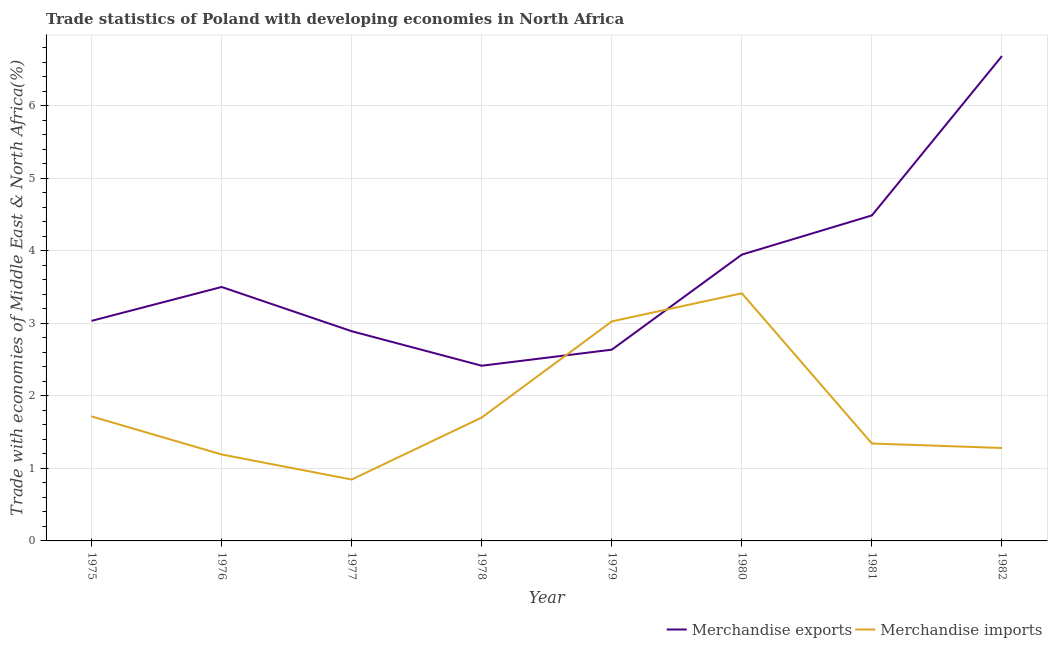Is the number of lines equal to the number of legend labels?
Make the answer very short. Yes. What is the merchandise exports in 1975?
Provide a short and direct response. 3.03. Across all years, what is the maximum merchandise exports?
Provide a short and direct response. 6.69. Across all years, what is the minimum merchandise exports?
Your response must be concise. 2.42. In which year was the merchandise exports minimum?
Make the answer very short. 1978. What is the total merchandise exports in the graph?
Your answer should be very brief. 29.6. What is the difference between the merchandise exports in 1976 and that in 1978?
Give a very brief answer. 1.09. What is the difference between the merchandise imports in 1976 and the merchandise exports in 1981?
Provide a short and direct response. -3.3. What is the average merchandise imports per year?
Your answer should be very brief. 1.82. In the year 1976, what is the difference between the merchandise imports and merchandise exports?
Give a very brief answer. -2.31. What is the ratio of the merchandise imports in 1978 to that in 1980?
Ensure brevity in your answer.  0.5. What is the difference between the highest and the second highest merchandise exports?
Offer a very short reply. 2.2. What is the difference between the highest and the lowest merchandise imports?
Your answer should be very brief. 2.57. In how many years, is the merchandise exports greater than the average merchandise exports taken over all years?
Provide a succinct answer. 3. How many years are there in the graph?
Offer a terse response. 8. What is the difference between two consecutive major ticks on the Y-axis?
Provide a short and direct response. 1. Are the values on the major ticks of Y-axis written in scientific E-notation?
Keep it short and to the point. No. Does the graph contain any zero values?
Ensure brevity in your answer.  No. How many legend labels are there?
Offer a terse response. 2. How are the legend labels stacked?
Keep it short and to the point. Horizontal. What is the title of the graph?
Offer a terse response. Trade statistics of Poland with developing economies in North Africa. What is the label or title of the Y-axis?
Offer a very short reply. Trade with economies of Middle East & North Africa(%). What is the Trade with economies of Middle East & North Africa(%) in Merchandise exports in 1975?
Provide a succinct answer. 3.03. What is the Trade with economies of Middle East & North Africa(%) in Merchandise imports in 1975?
Your answer should be very brief. 1.72. What is the Trade with economies of Middle East & North Africa(%) of Merchandise exports in 1976?
Provide a short and direct response. 3.5. What is the Trade with economies of Middle East & North Africa(%) of Merchandise imports in 1976?
Offer a terse response. 1.19. What is the Trade with economies of Middle East & North Africa(%) of Merchandise exports in 1977?
Ensure brevity in your answer.  2.89. What is the Trade with economies of Middle East & North Africa(%) in Merchandise imports in 1977?
Offer a terse response. 0.85. What is the Trade with economies of Middle East & North Africa(%) in Merchandise exports in 1978?
Provide a short and direct response. 2.42. What is the Trade with economies of Middle East & North Africa(%) in Merchandise imports in 1978?
Make the answer very short. 1.7. What is the Trade with economies of Middle East & North Africa(%) in Merchandise exports in 1979?
Your answer should be very brief. 2.64. What is the Trade with economies of Middle East & North Africa(%) in Merchandise imports in 1979?
Give a very brief answer. 3.03. What is the Trade with economies of Middle East & North Africa(%) of Merchandise exports in 1980?
Give a very brief answer. 3.95. What is the Trade with economies of Middle East & North Africa(%) of Merchandise imports in 1980?
Make the answer very short. 3.41. What is the Trade with economies of Middle East & North Africa(%) in Merchandise exports in 1981?
Keep it short and to the point. 4.49. What is the Trade with economies of Middle East & North Africa(%) in Merchandise imports in 1981?
Provide a short and direct response. 1.34. What is the Trade with economies of Middle East & North Africa(%) of Merchandise exports in 1982?
Offer a very short reply. 6.69. What is the Trade with economies of Middle East & North Africa(%) of Merchandise imports in 1982?
Offer a terse response. 1.28. Across all years, what is the maximum Trade with economies of Middle East & North Africa(%) of Merchandise exports?
Make the answer very short. 6.69. Across all years, what is the maximum Trade with economies of Middle East & North Africa(%) in Merchandise imports?
Provide a succinct answer. 3.41. Across all years, what is the minimum Trade with economies of Middle East & North Africa(%) in Merchandise exports?
Make the answer very short. 2.42. Across all years, what is the minimum Trade with economies of Middle East & North Africa(%) of Merchandise imports?
Give a very brief answer. 0.85. What is the total Trade with economies of Middle East & North Africa(%) of Merchandise exports in the graph?
Provide a short and direct response. 29.6. What is the total Trade with economies of Middle East & North Africa(%) in Merchandise imports in the graph?
Offer a terse response. 14.52. What is the difference between the Trade with economies of Middle East & North Africa(%) in Merchandise exports in 1975 and that in 1976?
Your response must be concise. -0.47. What is the difference between the Trade with economies of Middle East & North Africa(%) in Merchandise imports in 1975 and that in 1976?
Your answer should be compact. 0.52. What is the difference between the Trade with economies of Middle East & North Africa(%) in Merchandise exports in 1975 and that in 1977?
Give a very brief answer. 0.14. What is the difference between the Trade with economies of Middle East & North Africa(%) of Merchandise imports in 1975 and that in 1977?
Provide a succinct answer. 0.87. What is the difference between the Trade with economies of Middle East & North Africa(%) in Merchandise exports in 1975 and that in 1978?
Your response must be concise. 0.62. What is the difference between the Trade with economies of Middle East & North Africa(%) in Merchandise imports in 1975 and that in 1978?
Provide a short and direct response. 0.02. What is the difference between the Trade with economies of Middle East & North Africa(%) of Merchandise exports in 1975 and that in 1979?
Provide a succinct answer. 0.4. What is the difference between the Trade with economies of Middle East & North Africa(%) in Merchandise imports in 1975 and that in 1979?
Keep it short and to the point. -1.31. What is the difference between the Trade with economies of Middle East & North Africa(%) of Merchandise exports in 1975 and that in 1980?
Make the answer very short. -0.91. What is the difference between the Trade with economies of Middle East & North Africa(%) of Merchandise imports in 1975 and that in 1980?
Provide a short and direct response. -1.7. What is the difference between the Trade with economies of Middle East & North Africa(%) of Merchandise exports in 1975 and that in 1981?
Offer a terse response. -1.45. What is the difference between the Trade with economies of Middle East & North Africa(%) of Merchandise imports in 1975 and that in 1981?
Ensure brevity in your answer.  0.37. What is the difference between the Trade with economies of Middle East & North Africa(%) of Merchandise exports in 1975 and that in 1982?
Your answer should be very brief. -3.65. What is the difference between the Trade with economies of Middle East & North Africa(%) of Merchandise imports in 1975 and that in 1982?
Your response must be concise. 0.44. What is the difference between the Trade with economies of Middle East & North Africa(%) of Merchandise exports in 1976 and that in 1977?
Keep it short and to the point. 0.61. What is the difference between the Trade with economies of Middle East & North Africa(%) of Merchandise imports in 1976 and that in 1977?
Provide a short and direct response. 0.35. What is the difference between the Trade with economies of Middle East & North Africa(%) in Merchandise exports in 1976 and that in 1978?
Your answer should be very brief. 1.09. What is the difference between the Trade with economies of Middle East & North Africa(%) of Merchandise imports in 1976 and that in 1978?
Provide a short and direct response. -0.51. What is the difference between the Trade with economies of Middle East & North Africa(%) in Merchandise exports in 1976 and that in 1979?
Your answer should be very brief. 0.86. What is the difference between the Trade with economies of Middle East & North Africa(%) in Merchandise imports in 1976 and that in 1979?
Your response must be concise. -1.83. What is the difference between the Trade with economies of Middle East & North Africa(%) of Merchandise exports in 1976 and that in 1980?
Keep it short and to the point. -0.45. What is the difference between the Trade with economies of Middle East & North Africa(%) in Merchandise imports in 1976 and that in 1980?
Your response must be concise. -2.22. What is the difference between the Trade with economies of Middle East & North Africa(%) of Merchandise exports in 1976 and that in 1981?
Keep it short and to the point. -0.99. What is the difference between the Trade with economies of Middle East & North Africa(%) of Merchandise imports in 1976 and that in 1981?
Your answer should be compact. -0.15. What is the difference between the Trade with economies of Middle East & North Africa(%) of Merchandise exports in 1976 and that in 1982?
Make the answer very short. -3.18. What is the difference between the Trade with economies of Middle East & North Africa(%) in Merchandise imports in 1976 and that in 1982?
Make the answer very short. -0.09. What is the difference between the Trade with economies of Middle East & North Africa(%) in Merchandise exports in 1977 and that in 1978?
Make the answer very short. 0.48. What is the difference between the Trade with economies of Middle East & North Africa(%) in Merchandise imports in 1977 and that in 1978?
Provide a short and direct response. -0.86. What is the difference between the Trade with economies of Middle East & North Africa(%) in Merchandise exports in 1977 and that in 1979?
Make the answer very short. 0.25. What is the difference between the Trade with economies of Middle East & North Africa(%) in Merchandise imports in 1977 and that in 1979?
Your answer should be very brief. -2.18. What is the difference between the Trade with economies of Middle East & North Africa(%) of Merchandise exports in 1977 and that in 1980?
Your answer should be compact. -1.06. What is the difference between the Trade with economies of Middle East & North Africa(%) in Merchandise imports in 1977 and that in 1980?
Your answer should be compact. -2.57. What is the difference between the Trade with economies of Middle East & North Africa(%) in Merchandise exports in 1977 and that in 1981?
Ensure brevity in your answer.  -1.6. What is the difference between the Trade with economies of Middle East & North Africa(%) in Merchandise imports in 1977 and that in 1981?
Offer a very short reply. -0.5. What is the difference between the Trade with economies of Middle East & North Africa(%) in Merchandise exports in 1977 and that in 1982?
Make the answer very short. -3.79. What is the difference between the Trade with economies of Middle East & North Africa(%) of Merchandise imports in 1977 and that in 1982?
Offer a very short reply. -0.44. What is the difference between the Trade with economies of Middle East & North Africa(%) in Merchandise exports in 1978 and that in 1979?
Give a very brief answer. -0.22. What is the difference between the Trade with economies of Middle East & North Africa(%) in Merchandise imports in 1978 and that in 1979?
Your answer should be compact. -1.33. What is the difference between the Trade with economies of Middle East & North Africa(%) in Merchandise exports in 1978 and that in 1980?
Offer a very short reply. -1.53. What is the difference between the Trade with economies of Middle East & North Africa(%) in Merchandise imports in 1978 and that in 1980?
Provide a succinct answer. -1.71. What is the difference between the Trade with economies of Middle East & North Africa(%) in Merchandise exports in 1978 and that in 1981?
Give a very brief answer. -2.07. What is the difference between the Trade with economies of Middle East & North Africa(%) in Merchandise imports in 1978 and that in 1981?
Make the answer very short. 0.36. What is the difference between the Trade with economies of Middle East & North Africa(%) in Merchandise exports in 1978 and that in 1982?
Ensure brevity in your answer.  -4.27. What is the difference between the Trade with economies of Middle East & North Africa(%) in Merchandise imports in 1978 and that in 1982?
Give a very brief answer. 0.42. What is the difference between the Trade with economies of Middle East & North Africa(%) in Merchandise exports in 1979 and that in 1980?
Offer a very short reply. -1.31. What is the difference between the Trade with economies of Middle East & North Africa(%) in Merchandise imports in 1979 and that in 1980?
Your response must be concise. -0.39. What is the difference between the Trade with economies of Middle East & North Africa(%) in Merchandise exports in 1979 and that in 1981?
Your answer should be compact. -1.85. What is the difference between the Trade with economies of Middle East & North Africa(%) in Merchandise imports in 1979 and that in 1981?
Offer a very short reply. 1.68. What is the difference between the Trade with economies of Middle East & North Africa(%) of Merchandise exports in 1979 and that in 1982?
Keep it short and to the point. -4.05. What is the difference between the Trade with economies of Middle East & North Africa(%) in Merchandise imports in 1979 and that in 1982?
Provide a succinct answer. 1.75. What is the difference between the Trade with economies of Middle East & North Africa(%) in Merchandise exports in 1980 and that in 1981?
Offer a terse response. -0.54. What is the difference between the Trade with economies of Middle East & North Africa(%) of Merchandise imports in 1980 and that in 1981?
Your answer should be very brief. 2.07. What is the difference between the Trade with economies of Middle East & North Africa(%) in Merchandise exports in 1980 and that in 1982?
Give a very brief answer. -2.74. What is the difference between the Trade with economies of Middle East & North Africa(%) in Merchandise imports in 1980 and that in 1982?
Provide a succinct answer. 2.13. What is the difference between the Trade with economies of Middle East & North Africa(%) in Merchandise exports in 1981 and that in 1982?
Your answer should be very brief. -2.2. What is the difference between the Trade with economies of Middle East & North Africa(%) in Merchandise imports in 1981 and that in 1982?
Your response must be concise. 0.06. What is the difference between the Trade with economies of Middle East & North Africa(%) of Merchandise exports in 1975 and the Trade with economies of Middle East & North Africa(%) of Merchandise imports in 1976?
Give a very brief answer. 1.84. What is the difference between the Trade with economies of Middle East & North Africa(%) in Merchandise exports in 1975 and the Trade with economies of Middle East & North Africa(%) in Merchandise imports in 1977?
Your response must be concise. 2.19. What is the difference between the Trade with economies of Middle East & North Africa(%) of Merchandise exports in 1975 and the Trade with economies of Middle East & North Africa(%) of Merchandise imports in 1978?
Your answer should be compact. 1.33. What is the difference between the Trade with economies of Middle East & North Africa(%) of Merchandise exports in 1975 and the Trade with economies of Middle East & North Africa(%) of Merchandise imports in 1979?
Ensure brevity in your answer.  0.01. What is the difference between the Trade with economies of Middle East & North Africa(%) in Merchandise exports in 1975 and the Trade with economies of Middle East & North Africa(%) in Merchandise imports in 1980?
Keep it short and to the point. -0.38. What is the difference between the Trade with economies of Middle East & North Africa(%) of Merchandise exports in 1975 and the Trade with economies of Middle East & North Africa(%) of Merchandise imports in 1981?
Keep it short and to the point. 1.69. What is the difference between the Trade with economies of Middle East & North Africa(%) of Merchandise exports in 1975 and the Trade with economies of Middle East & North Africa(%) of Merchandise imports in 1982?
Provide a short and direct response. 1.75. What is the difference between the Trade with economies of Middle East & North Africa(%) of Merchandise exports in 1976 and the Trade with economies of Middle East & North Africa(%) of Merchandise imports in 1977?
Keep it short and to the point. 2.65. What is the difference between the Trade with economies of Middle East & North Africa(%) of Merchandise exports in 1976 and the Trade with economies of Middle East & North Africa(%) of Merchandise imports in 1978?
Offer a very short reply. 1.8. What is the difference between the Trade with economies of Middle East & North Africa(%) of Merchandise exports in 1976 and the Trade with economies of Middle East & North Africa(%) of Merchandise imports in 1979?
Ensure brevity in your answer.  0.47. What is the difference between the Trade with economies of Middle East & North Africa(%) in Merchandise exports in 1976 and the Trade with economies of Middle East & North Africa(%) in Merchandise imports in 1980?
Ensure brevity in your answer.  0.09. What is the difference between the Trade with economies of Middle East & North Africa(%) in Merchandise exports in 1976 and the Trade with economies of Middle East & North Africa(%) in Merchandise imports in 1981?
Offer a terse response. 2.16. What is the difference between the Trade with economies of Middle East & North Africa(%) in Merchandise exports in 1976 and the Trade with economies of Middle East & North Africa(%) in Merchandise imports in 1982?
Keep it short and to the point. 2.22. What is the difference between the Trade with economies of Middle East & North Africa(%) in Merchandise exports in 1977 and the Trade with economies of Middle East & North Africa(%) in Merchandise imports in 1978?
Give a very brief answer. 1.19. What is the difference between the Trade with economies of Middle East & North Africa(%) of Merchandise exports in 1977 and the Trade with economies of Middle East & North Africa(%) of Merchandise imports in 1979?
Offer a very short reply. -0.14. What is the difference between the Trade with economies of Middle East & North Africa(%) of Merchandise exports in 1977 and the Trade with economies of Middle East & North Africa(%) of Merchandise imports in 1980?
Give a very brief answer. -0.52. What is the difference between the Trade with economies of Middle East & North Africa(%) in Merchandise exports in 1977 and the Trade with economies of Middle East & North Africa(%) in Merchandise imports in 1981?
Offer a very short reply. 1.55. What is the difference between the Trade with economies of Middle East & North Africa(%) in Merchandise exports in 1977 and the Trade with economies of Middle East & North Africa(%) in Merchandise imports in 1982?
Ensure brevity in your answer.  1.61. What is the difference between the Trade with economies of Middle East & North Africa(%) in Merchandise exports in 1978 and the Trade with economies of Middle East & North Africa(%) in Merchandise imports in 1979?
Keep it short and to the point. -0.61. What is the difference between the Trade with economies of Middle East & North Africa(%) in Merchandise exports in 1978 and the Trade with economies of Middle East & North Africa(%) in Merchandise imports in 1980?
Make the answer very short. -1. What is the difference between the Trade with economies of Middle East & North Africa(%) of Merchandise exports in 1978 and the Trade with economies of Middle East & North Africa(%) of Merchandise imports in 1981?
Keep it short and to the point. 1.07. What is the difference between the Trade with economies of Middle East & North Africa(%) in Merchandise exports in 1978 and the Trade with economies of Middle East & North Africa(%) in Merchandise imports in 1982?
Ensure brevity in your answer.  1.13. What is the difference between the Trade with economies of Middle East & North Africa(%) of Merchandise exports in 1979 and the Trade with economies of Middle East & North Africa(%) of Merchandise imports in 1980?
Your answer should be compact. -0.78. What is the difference between the Trade with economies of Middle East & North Africa(%) in Merchandise exports in 1979 and the Trade with economies of Middle East & North Africa(%) in Merchandise imports in 1981?
Offer a very short reply. 1.29. What is the difference between the Trade with economies of Middle East & North Africa(%) in Merchandise exports in 1979 and the Trade with economies of Middle East & North Africa(%) in Merchandise imports in 1982?
Your answer should be compact. 1.36. What is the difference between the Trade with economies of Middle East & North Africa(%) of Merchandise exports in 1980 and the Trade with economies of Middle East & North Africa(%) of Merchandise imports in 1981?
Offer a very short reply. 2.6. What is the difference between the Trade with economies of Middle East & North Africa(%) of Merchandise exports in 1980 and the Trade with economies of Middle East & North Africa(%) of Merchandise imports in 1982?
Make the answer very short. 2.67. What is the difference between the Trade with economies of Middle East & North Africa(%) of Merchandise exports in 1981 and the Trade with economies of Middle East & North Africa(%) of Merchandise imports in 1982?
Ensure brevity in your answer.  3.21. What is the average Trade with economies of Middle East & North Africa(%) in Merchandise imports per year?
Your answer should be very brief. 1.82. In the year 1975, what is the difference between the Trade with economies of Middle East & North Africa(%) of Merchandise exports and Trade with economies of Middle East & North Africa(%) of Merchandise imports?
Provide a short and direct response. 1.32. In the year 1976, what is the difference between the Trade with economies of Middle East & North Africa(%) of Merchandise exports and Trade with economies of Middle East & North Africa(%) of Merchandise imports?
Provide a short and direct response. 2.31. In the year 1977, what is the difference between the Trade with economies of Middle East & North Africa(%) of Merchandise exports and Trade with economies of Middle East & North Africa(%) of Merchandise imports?
Keep it short and to the point. 2.04. In the year 1978, what is the difference between the Trade with economies of Middle East & North Africa(%) in Merchandise exports and Trade with economies of Middle East & North Africa(%) in Merchandise imports?
Offer a very short reply. 0.71. In the year 1979, what is the difference between the Trade with economies of Middle East & North Africa(%) in Merchandise exports and Trade with economies of Middle East & North Africa(%) in Merchandise imports?
Offer a terse response. -0.39. In the year 1980, what is the difference between the Trade with economies of Middle East & North Africa(%) in Merchandise exports and Trade with economies of Middle East & North Africa(%) in Merchandise imports?
Your answer should be very brief. 0.53. In the year 1981, what is the difference between the Trade with economies of Middle East & North Africa(%) of Merchandise exports and Trade with economies of Middle East & North Africa(%) of Merchandise imports?
Give a very brief answer. 3.14. In the year 1982, what is the difference between the Trade with economies of Middle East & North Africa(%) of Merchandise exports and Trade with economies of Middle East & North Africa(%) of Merchandise imports?
Make the answer very short. 5.4. What is the ratio of the Trade with economies of Middle East & North Africa(%) in Merchandise exports in 1975 to that in 1976?
Give a very brief answer. 0.87. What is the ratio of the Trade with economies of Middle East & North Africa(%) in Merchandise imports in 1975 to that in 1976?
Offer a terse response. 1.44. What is the ratio of the Trade with economies of Middle East & North Africa(%) of Merchandise exports in 1975 to that in 1977?
Ensure brevity in your answer.  1.05. What is the ratio of the Trade with economies of Middle East & North Africa(%) of Merchandise imports in 1975 to that in 1977?
Your answer should be compact. 2.03. What is the ratio of the Trade with economies of Middle East & North Africa(%) of Merchandise exports in 1975 to that in 1978?
Your answer should be very brief. 1.26. What is the ratio of the Trade with economies of Middle East & North Africa(%) of Merchandise exports in 1975 to that in 1979?
Your response must be concise. 1.15. What is the ratio of the Trade with economies of Middle East & North Africa(%) in Merchandise imports in 1975 to that in 1979?
Offer a terse response. 0.57. What is the ratio of the Trade with economies of Middle East & North Africa(%) of Merchandise exports in 1975 to that in 1980?
Offer a terse response. 0.77. What is the ratio of the Trade with economies of Middle East & North Africa(%) in Merchandise imports in 1975 to that in 1980?
Make the answer very short. 0.5. What is the ratio of the Trade with economies of Middle East & North Africa(%) in Merchandise exports in 1975 to that in 1981?
Your answer should be very brief. 0.68. What is the ratio of the Trade with economies of Middle East & North Africa(%) in Merchandise imports in 1975 to that in 1981?
Offer a very short reply. 1.28. What is the ratio of the Trade with economies of Middle East & North Africa(%) of Merchandise exports in 1975 to that in 1982?
Offer a very short reply. 0.45. What is the ratio of the Trade with economies of Middle East & North Africa(%) in Merchandise imports in 1975 to that in 1982?
Keep it short and to the point. 1.34. What is the ratio of the Trade with economies of Middle East & North Africa(%) of Merchandise exports in 1976 to that in 1977?
Your answer should be very brief. 1.21. What is the ratio of the Trade with economies of Middle East & North Africa(%) of Merchandise imports in 1976 to that in 1977?
Your answer should be compact. 1.41. What is the ratio of the Trade with economies of Middle East & North Africa(%) in Merchandise exports in 1976 to that in 1978?
Your answer should be very brief. 1.45. What is the ratio of the Trade with economies of Middle East & North Africa(%) of Merchandise imports in 1976 to that in 1978?
Your answer should be very brief. 0.7. What is the ratio of the Trade with economies of Middle East & North Africa(%) in Merchandise exports in 1976 to that in 1979?
Make the answer very short. 1.33. What is the ratio of the Trade with economies of Middle East & North Africa(%) of Merchandise imports in 1976 to that in 1979?
Your response must be concise. 0.39. What is the ratio of the Trade with economies of Middle East & North Africa(%) in Merchandise exports in 1976 to that in 1980?
Offer a terse response. 0.89. What is the ratio of the Trade with economies of Middle East & North Africa(%) of Merchandise imports in 1976 to that in 1980?
Keep it short and to the point. 0.35. What is the ratio of the Trade with economies of Middle East & North Africa(%) of Merchandise exports in 1976 to that in 1981?
Your answer should be very brief. 0.78. What is the ratio of the Trade with economies of Middle East & North Africa(%) of Merchandise imports in 1976 to that in 1981?
Ensure brevity in your answer.  0.89. What is the ratio of the Trade with economies of Middle East & North Africa(%) in Merchandise exports in 1976 to that in 1982?
Ensure brevity in your answer.  0.52. What is the ratio of the Trade with economies of Middle East & North Africa(%) of Merchandise imports in 1976 to that in 1982?
Ensure brevity in your answer.  0.93. What is the ratio of the Trade with economies of Middle East & North Africa(%) of Merchandise exports in 1977 to that in 1978?
Make the answer very short. 1.2. What is the ratio of the Trade with economies of Middle East & North Africa(%) in Merchandise imports in 1977 to that in 1978?
Provide a short and direct response. 0.5. What is the ratio of the Trade with economies of Middle East & North Africa(%) in Merchandise exports in 1977 to that in 1979?
Your answer should be very brief. 1.1. What is the ratio of the Trade with economies of Middle East & North Africa(%) of Merchandise imports in 1977 to that in 1979?
Make the answer very short. 0.28. What is the ratio of the Trade with economies of Middle East & North Africa(%) in Merchandise exports in 1977 to that in 1980?
Keep it short and to the point. 0.73. What is the ratio of the Trade with economies of Middle East & North Africa(%) of Merchandise imports in 1977 to that in 1980?
Your response must be concise. 0.25. What is the ratio of the Trade with economies of Middle East & North Africa(%) in Merchandise exports in 1977 to that in 1981?
Ensure brevity in your answer.  0.64. What is the ratio of the Trade with economies of Middle East & North Africa(%) in Merchandise imports in 1977 to that in 1981?
Make the answer very short. 0.63. What is the ratio of the Trade with economies of Middle East & North Africa(%) in Merchandise exports in 1977 to that in 1982?
Your response must be concise. 0.43. What is the ratio of the Trade with economies of Middle East & North Africa(%) of Merchandise imports in 1977 to that in 1982?
Keep it short and to the point. 0.66. What is the ratio of the Trade with economies of Middle East & North Africa(%) of Merchandise exports in 1978 to that in 1979?
Give a very brief answer. 0.92. What is the ratio of the Trade with economies of Middle East & North Africa(%) of Merchandise imports in 1978 to that in 1979?
Offer a terse response. 0.56. What is the ratio of the Trade with economies of Middle East & North Africa(%) in Merchandise exports in 1978 to that in 1980?
Provide a succinct answer. 0.61. What is the ratio of the Trade with economies of Middle East & North Africa(%) of Merchandise imports in 1978 to that in 1980?
Offer a very short reply. 0.5. What is the ratio of the Trade with economies of Middle East & North Africa(%) of Merchandise exports in 1978 to that in 1981?
Offer a very short reply. 0.54. What is the ratio of the Trade with economies of Middle East & North Africa(%) in Merchandise imports in 1978 to that in 1981?
Make the answer very short. 1.27. What is the ratio of the Trade with economies of Middle East & North Africa(%) in Merchandise exports in 1978 to that in 1982?
Provide a short and direct response. 0.36. What is the ratio of the Trade with economies of Middle East & North Africa(%) in Merchandise imports in 1978 to that in 1982?
Your answer should be compact. 1.33. What is the ratio of the Trade with economies of Middle East & North Africa(%) in Merchandise exports in 1979 to that in 1980?
Your answer should be compact. 0.67. What is the ratio of the Trade with economies of Middle East & North Africa(%) of Merchandise imports in 1979 to that in 1980?
Give a very brief answer. 0.89. What is the ratio of the Trade with economies of Middle East & North Africa(%) of Merchandise exports in 1979 to that in 1981?
Keep it short and to the point. 0.59. What is the ratio of the Trade with economies of Middle East & North Africa(%) of Merchandise imports in 1979 to that in 1981?
Your response must be concise. 2.25. What is the ratio of the Trade with economies of Middle East & North Africa(%) of Merchandise exports in 1979 to that in 1982?
Offer a terse response. 0.39. What is the ratio of the Trade with economies of Middle East & North Africa(%) in Merchandise imports in 1979 to that in 1982?
Ensure brevity in your answer.  2.36. What is the ratio of the Trade with economies of Middle East & North Africa(%) of Merchandise exports in 1980 to that in 1981?
Provide a succinct answer. 0.88. What is the ratio of the Trade with economies of Middle East & North Africa(%) in Merchandise imports in 1980 to that in 1981?
Offer a very short reply. 2.54. What is the ratio of the Trade with economies of Middle East & North Africa(%) in Merchandise exports in 1980 to that in 1982?
Make the answer very short. 0.59. What is the ratio of the Trade with economies of Middle East & North Africa(%) of Merchandise imports in 1980 to that in 1982?
Keep it short and to the point. 2.66. What is the ratio of the Trade with economies of Middle East & North Africa(%) in Merchandise exports in 1981 to that in 1982?
Ensure brevity in your answer.  0.67. What is the ratio of the Trade with economies of Middle East & North Africa(%) of Merchandise imports in 1981 to that in 1982?
Provide a short and direct response. 1.05. What is the difference between the highest and the second highest Trade with economies of Middle East & North Africa(%) in Merchandise exports?
Offer a terse response. 2.2. What is the difference between the highest and the second highest Trade with economies of Middle East & North Africa(%) of Merchandise imports?
Keep it short and to the point. 0.39. What is the difference between the highest and the lowest Trade with economies of Middle East & North Africa(%) in Merchandise exports?
Keep it short and to the point. 4.27. What is the difference between the highest and the lowest Trade with economies of Middle East & North Africa(%) of Merchandise imports?
Provide a short and direct response. 2.57. 